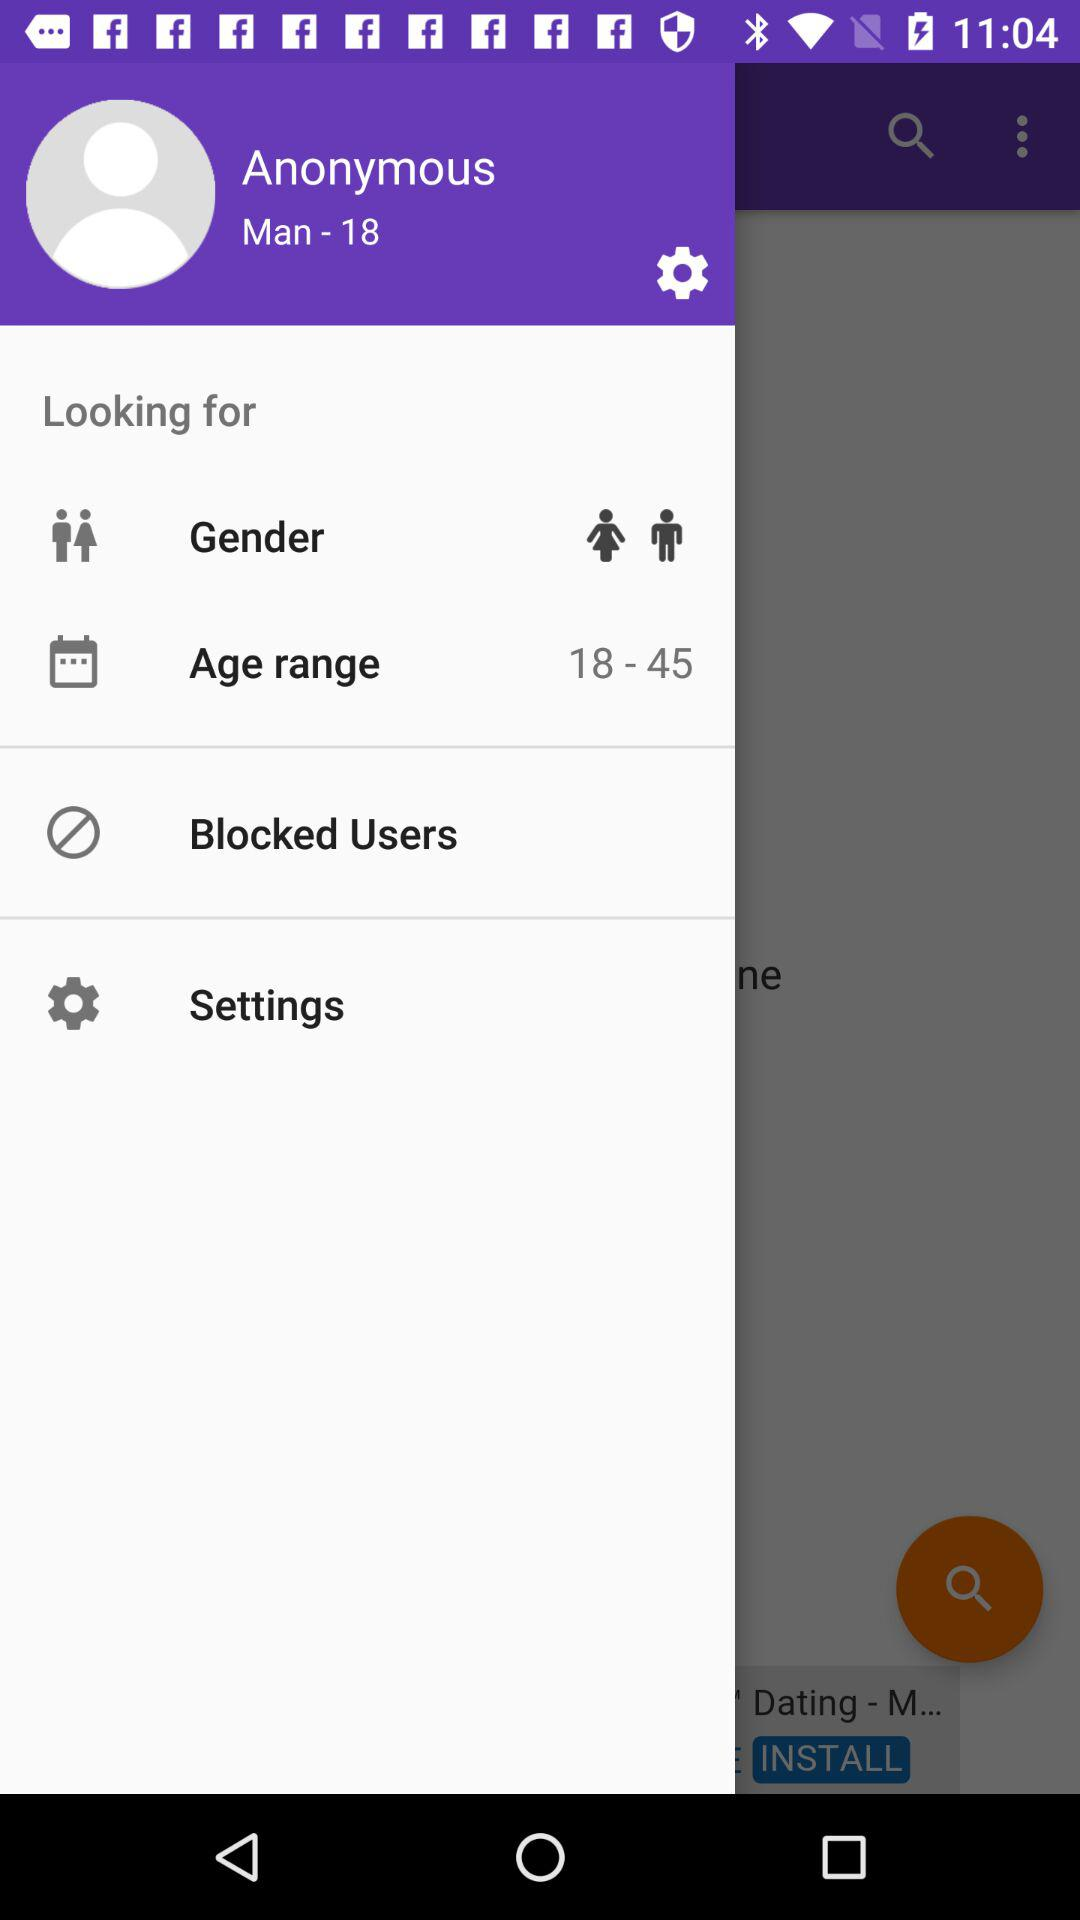What is the age range? The age range is from 18 to 45. 